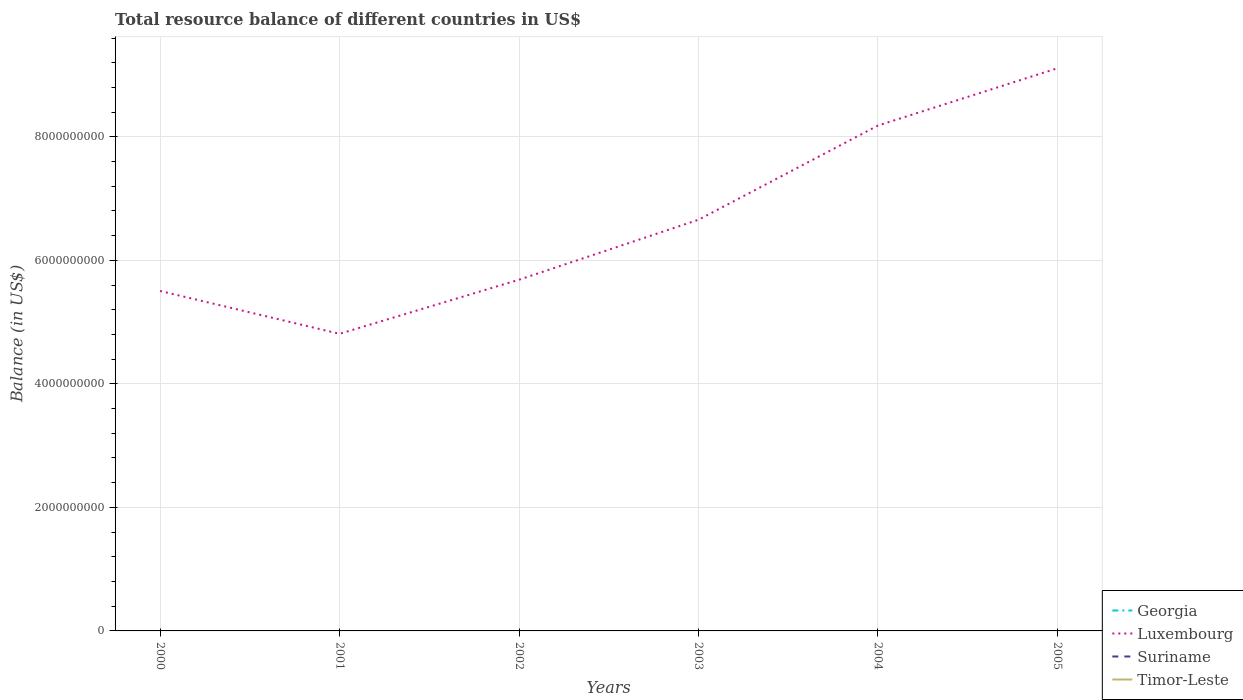How many different coloured lines are there?
Make the answer very short. 1. What is the total total resource balance in Luxembourg in the graph?
Your response must be concise. -3.42e+09. What is the difference between the highest and the second highest total resource balance in Luxembourg?
Your response must be concise. 4.30e+09. What is the difference between the highest and the lowest total resource balance in Suriname?
Ensure brevity in your answer.  0. Is the total resource balance in Timor-Leste strictly greater than the total resource balance in Suriname over the years?
Your response must be concise. Yes. How many lines are there?
Give a very brief answer. 1. What is the difference between two consecutive major ticks on the Y-axis?
Your response must be concise. 2.00e+09. Does the graph contain any zero values?
Keep it short and to the point. Yes. What is the title of the graph?
Give a very brief answer. Total resource balance of different countries in US$. Does "Paraguay" appear as one of the legend labels in the graph?
Offer a terse response. No. What is the label or title of the Y-axis?
Your answer should be compact. Balance (in US$). What is the Balance (in US$) of Georgia in 2000?
Give a very brief answer. 0. What is the Balance (in US$) in Luxembourg in 2000?
Offer a very short reply. 5.50e+09. What is the Balance (in US$) of Timor-Leste in 2000?
Offer a very short reply. 0. What is the Balance (in US$) in Georgia in 2001?
Keep it short and to the point. 0. What is the Balance (in US$) in Luxembourg in 2001?
Offer a terse response. 4.81e+09. What is the Balance (in US$) of Timor-Leste in 2001?
Offer a terse response. 0. What is the Balance (in US$) in Luxembourg in 2002?
Give a very brief answer. 5.69e+09. What is the Balance (in US$) in Luxembourg in 2003?
Make the answer very short. 6.66e+09. What is the Balance (in US$) in Luxembourg in 2004?
Make the answer very short. 8.18e+09. What is the Balance (in US$) of Timor-Leste in 2004?
Your answer should be very brief. 0. What is the Balance (in US$) of Georgia in 2005?
Offer a terse response. 0. What is the Balance (in US$) in Luxembourg in 2005?
Provide a short and direct response. 9.11e+09. What is the Balance (in US$) in Suriname in 2005?
Provide a short and direct response. 0. Across all years, what is the maximum Balance (in US$) in Luxembourg?
Provide a succinct answer. 9.11e+09. Across all years, what is the minimum Balance (in US$) in Luxembourg?
Your answer should be compact. 4.81e+09. What is the total Balance (in US$) of Georgia in the graph?
Keep it short and to the point. 0. What is the total Balance (in US$) of Luxembourg in the graph?
Your answer should be compact. 4.00e+1. What is the difference between the Balance (in US$) in Luxembourg in 2000 and that in 2001?
Offer a terse response. 6.94e+08. What is the difference between the Balance (in US$) in Luxembourg in 2000 and that in 2002?
Ensure brevity in your answer.  -1.81e+08. What is the difference between the Balance (in US$) in Luxembourg in 2000 and that in 2003?
Keep it short and to the point. -1.15e+09. What is the difference between the Balance (in US$) in Luxembourg in 2000 and that in 2004?
Your answer should be compact. -2.68e+09. What is the difference between the Balance (in US$) in Luxembourg in 2000 and that in 2005?
Provide a succinct answer. -3.61e+09. What is the difference between the Balance (in US$) in Luxembourg in 2001 and that in 2002?
Provide a succinct answer. -8.75e+08. What is the difference between the Balance (in US$) of Luxembourg in 2001 and that in 2003?
Offer a terse response. -1.85e+09. What is the difference between the Balance (in US$) in Luxembourg in 2001 and that in 2004?
Ensure brevity in your answer.  -3.37e+09. What is the difference between the Balance (in US$) of Luxembourg in 2001 and that in 2005?
Offer a very short reply. -4.30e+09. What is the difference between the Balance (in US$) in Luxembourg in 2002 and that in 2003?
Ensure brevity in your answer.  -9.72e+08. What is the difference between the Balance (in US$) of Luxembourg in 2002 and that in 2004?
Make the answer very short. -2.50e+09. What is the difference between the Balance (in US$) of Luxembourg in 2002 and that in 2005?
Keep it short and to the point. -3.42e+09. What is the difference between the Balance (in US$) in Luxembourg in 2003 and that in 2004?
Offer a very short reply. -1.53e+09. What is the difference between the Balance (in US$) of Luxembourg in 2003 and that in 2005?
Ensure brevity in your answer.  -2.45e+09. What is the difference between the Balance (in US$) of Luxembourg in 2004 and that in 2005?
Offer a very short reply. -9.28e+08. What is the average Balance (in US$) in Georgia per year?
Your answer should be very brief. 0. What is the average Balance (in US$) in Luxembourg per year?
Offer a very short reply. 6.66e+09. What is the average Balance (in US$) in Timor-Leste per year?
Make the answer very short. 0. What is the ratio of the Balance (in US$) in Luxembourg in 2000 to that in 2001?
Your response must be concise. 1.14. What is the ratio of the Balance (in US$) in Luxembourg in 2000 to that in 2002?
Offer a terse response. 0.97. What is the ratio of the Balance (in US$) in Luxembourg in 2000 to that in 2003?
Offer a very short reply. 0.83. What is the ratio of the Balance (in US$) of Luxembourg in 2000 to that in 2004?
Ensure brevity in your answer.  0.67. What is the ratio of the Balance (in US$) in Luxembourg in 2000 to that in 2005?
Offer a very short reply. 0.6. What is the ratio of the Balance (in US$) in Luxembourg in 2001 to that in 2002?
Ensure brevity in your answer.  0.85. What is the ratio of the Balance (in US$) of Luxembourg in 2001 to that in 2003?
Your response must be concise. 0.72. What is the ratio of the Balance (in US$) of Luxembourg in 2001 to that in 2004?
Offer a terse response. 0.59. What is the ratio of the Balance (in US$) in Luxembourg in 2001 to that in 2005?
Your answer should be very brief. 0.53. What is the ratio of the Balance (in US$) in Luxembourg in 2002 to that in 2003?
Provide a succinct answer. 0.85. What is the ratio of the Balance (in US$) of Luxembourg in 2002 to that in 2004?
Your response must be concise. 0.69. What is the ratio of the Balance (in US$) in Luxembourg in 2002 to that in 2005?
Offer a very short reply. 0.62. What is the ratio of the Balance (in US$) in Luxembourg in 2003 to that in 2004?
Make the answer very short. 0.81. What is the ratio of the Balance (in US$) of Luxembourg in 2003 to that in 2005?
Make the answer very short. 0.73. What is the ratio of the Balance (in US$) in Luxembourg in 2004 to that in 2005?
Offer a terse response. 0.9. What is the difference between the highest and the second highest Balance (in US$) of Luxembourg?
Provide a short and direct response. 9.28e+08. What is the difference between the highest and the lowest Balance (in US$) in Luxembourg?
Your answer should be very brief. 4.30e+09. 